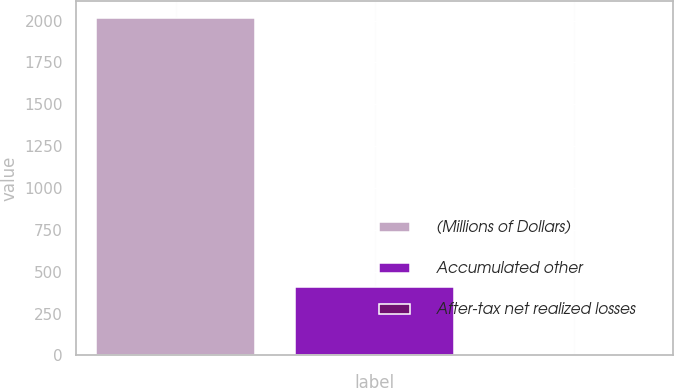<chart> <loc_0><loc_0><loc_500><loc_500><bar_chart><fcel>(Millions of Dollars)<fcel>Accumulated other<fcel>After-tax net realized losses<nl><fcel>2017<fcel>405.8<fcel>3<nl></chart> 